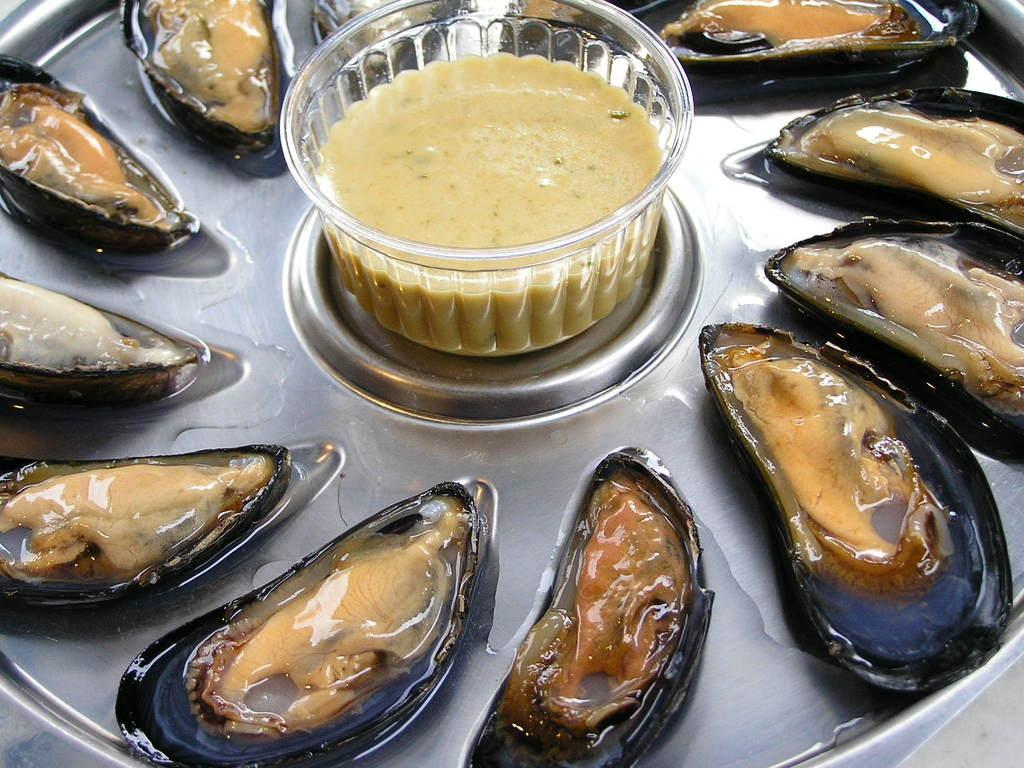What type of container is holding food in the image? There is food on a plate and in a bowl in the image. Can you describe the food in the plate and the bowl? The facts provided do not specify the type of food in the plate or the bowl. What color are the jeans worn by the van in the image? There is no van or jeans present in the image. What thrill can be experienced by the food in the image? The food in the image is stationary and does not experience any thrill. 